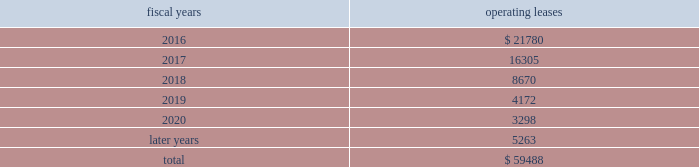Analog devices , inc .
Notes to consolidated financial statements 2014 ( continued ) the following is a schedule of future minimum rental payments required under long-term operating leases at october 31 , operating fiscal years leases .
12 .
Commitments and contingencies from time to time , in the ordinary course of the company 2019s business , various claims , charges and litigation are asserted or commenced against the company arising from , or related to , contractual matters , patents , trademarks , personal injury , environmental matters , product liability , insurance coverage and personnel and employment disputes .
As to such claims and litigation , the company can give no assurance that it will prevail .
The company does not believe that any current legal matters will have a material adverse effect on the company 2019s financial position , results of operations or cash flows .
13 .
Retirement plans the company and its subsidiaries have various savings and retirement plans covering substantially all employees .
The company maintains a defined contribution plan for the benefit of its eligible u.s .
Employees .
This plan provides for company contributions of up to 5% ( 5 % ) of each participant 2019s total eligible compensation .
In addition , the company contributes an amount equal to each participant 2019s pre-tax contribution , if any , up to a maximum of 3% ( 3 % ) of each participant 2019s total eligible compensation .
The total expense related to the defined contribution plan for u.s .
Employees was $ 26.3 million in fiscal 2015 , $ 24.1 million in fiscal 2014 and $ 23.1 million in fiscal 2013 .
The company also has various defined benefit pension and other retirement plans for certain non-u.s .
Employees that are consistent with local statutory requirements and practices .
The total expense related to the various defined benefit pension and other retirement plans for certain non-u.s .
Employees , excluding settlement charges related to the company's irish defined benefit plan , was $ 33.3 million in fiscal 2015 , $ 29.8 million in fiscal 2014 and $ 26.5 million in fiscal 2013 .
Non-u.s .
Plan disclosures during fiscal 2015 , the company converted the benefits provided to participants in the company 2019s irish defined benefits pension plan ( the db plan ) to benefits provided under the company 2019s irish defined contribution plan .
As a result , in fiscal 2015 the company recorded expenses of $ 223.7 million , including settlement charges , legal , accounting and other professional fees to settle the pension obligation .
The assets related to the db plan were liquidated and used to purchase annuities for retirees and distributed to active and deferred members' accounts in the company's irish defined contribution plan in connection with the plan conversion .
Accordingly , plan assets for the db plan were zero as of the end of fiscal 2015 .
The company 2019s funding policy for its foreign defined benefit pension plans is consistent with the local requirements of each country .
The plans 2019 assets consist primarily of u.s .
And non-u.s .
Equity securities , bonds , property and cash .
The benefit obligations and related assets under these plans have been measured at october 31 , 2015 and november 1 , 2014 .
Components of net periodic benefit cost net annual periodic pension cost of non-u.s .
Plans is presented in the following table: .
What was the total expense for the company contribution plan from 2013 to 2015? 
Rationale: in order to find the total expense one must added up all the expenses for the 4 years for both the us and non-us contribution plans .
Computations: (((29.8 + 26.5) + (23.1 + 24.1)) + (26.3 + 33.3))
Answer: 163.1. 